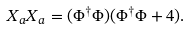Convert formula to latex. <formula><loc_0><loc_0><loc_500><loc_500>X _ { a } X _ { a } = ( \Phi ^ { \dagger } \Phi ) ( \Phi ^ { \dagger } \Phi + 4 ) .</formula> 